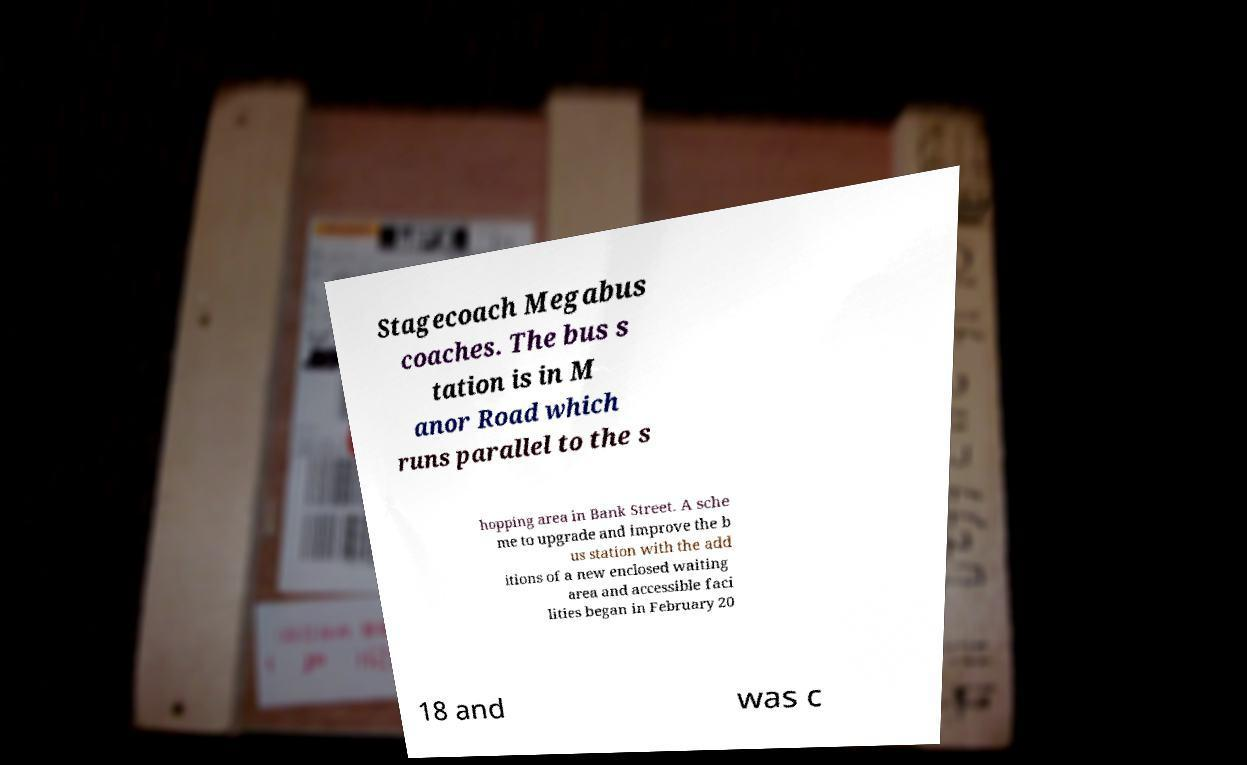For documentation purposes, I need the text within this image transcribed. Could you provide that? Stagecoach Megabus coaches. The bus s tation is in M anor Road which runs parallel to the s hopping area in Bank Street. A sche me to upgrade and improve the b us station with the add itions of a new enclosed waiting area and accessible faci lities began in February 20 18 and was c 